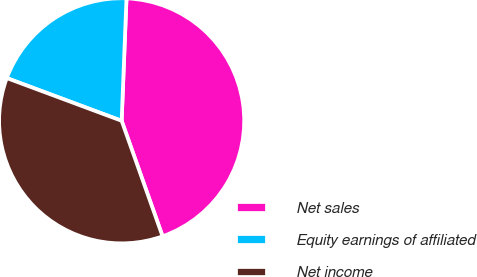Convert chart to OTSL. <chart><loc_0><loc_0><loc_500><loc_500><pie_chart><fcel>Net sales<fcel>Equity earnings of affiliated<fcel>Net income<nl><fcel>43.95%<fcel>19.96%<fcel>36.09%<nl></chart> 